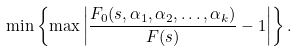Convert formula to latex. <formula><loc_0><loc_0><loc_500><loc_500>\min \left \{ \max \left | \frac { F _ { 0 } ( s , \alpha _ { 1 } , \alpha _ { 2 } , \dots , \alpha _ { k } ) } { F ( s ) } - 1 \right | \right \} .</formula> 